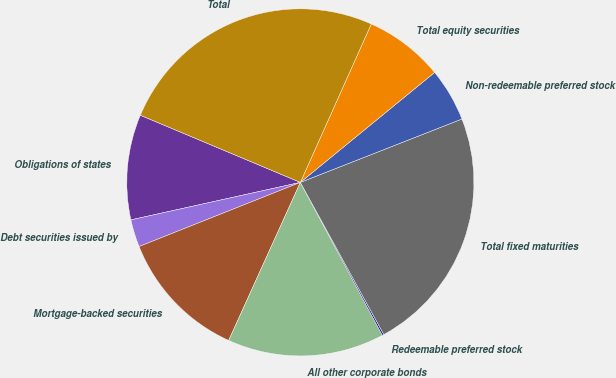Convert chart. <chart><loc_0><loc_0><loc_500><loc_500><pie_chart><fcel>Obligations of states<fcel>Debt securities issued by<fcel>Mortgage-backed securities<fcel>All other corporate bonds<fcel>Redeemable preferred stock<fcel>Total fixed maturities<fcel>Non-redeemable preferred stock<fcel>Total equity securities<fcel>Total<nl><fcel>9.79%<fcel>2.56%<fcel>12.2%<fcel>14.61%<fcel>0.15%<fcel>22.97%<fcel>4.97%<fcel>7.38%<fcel>25.38%<nl></chart> 